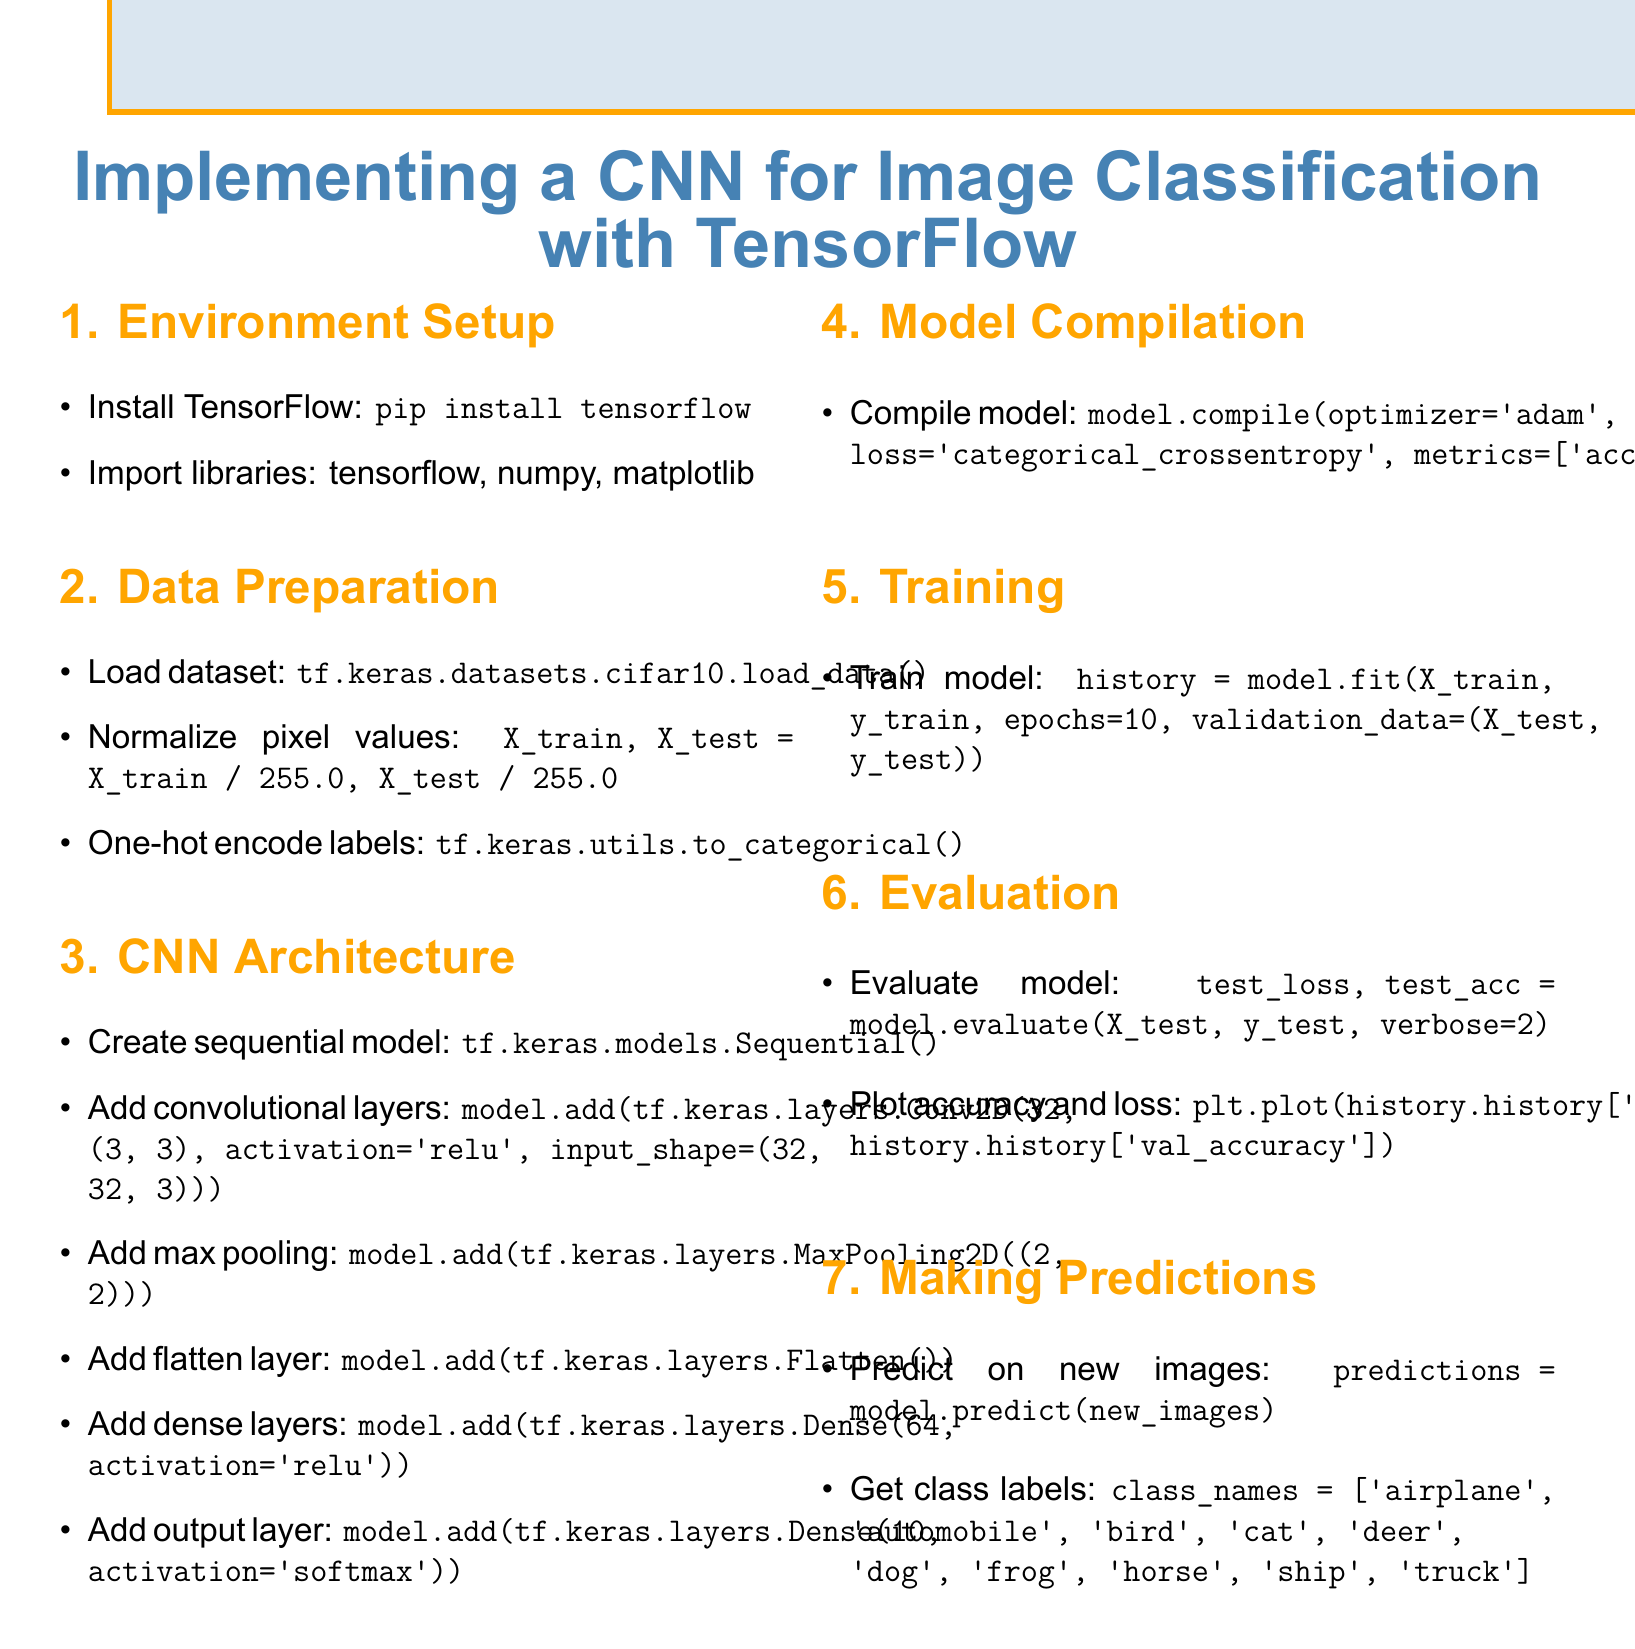What is the first step in setting up the environment? The first step is to install TensorFlow.
Answer: Install TensorFlow What library is used for one-hot encoding labels? The library used for one-hot encoding is tf.keras.utils.
Answer: tf.keras.utils How many convolutional layers are added to the model? Only one convolutional layer is specified in the document.
Answer: One What is the activation function used in the output layer? The output layer uses the softmax activation function.
Answer: softmax How many epochs are specified for training the model? The model is trained for 10 epochs.
Answer: 10 What is the purpose of the MaxPooling2D layer? The MaxPooling2D layer is added after convolutional layers, typically for downsampling.
Answer: Downsampling Which dataset is used in this implementation? The dataset used is CIFAR-10.
Answer: CIFAR-10 What metric is used for evaluating the model? The model evaluation metric is accuracy.
Answer: Accuracy What visualizes model performance over epochs? The accuracy and loss are plotted to visualize performance.
Answer: Plot accuracy and loss 